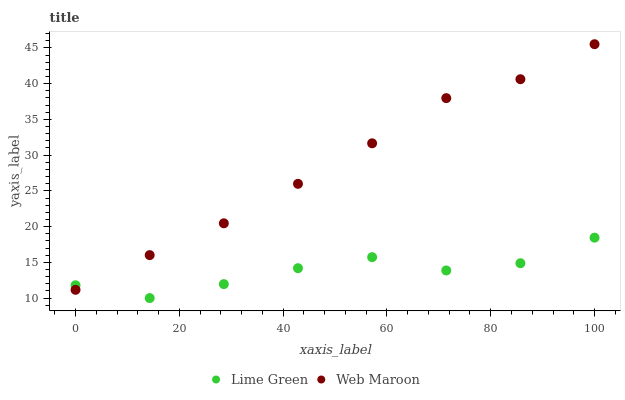Does Lime Green have the minimum area under the curve?
Answer yes or no. Yes. Does Web Maroon have the maximum area under the curve?
Answer yes or no. Yes. Does Lime Green have the maximum area under the curve?
Answer yes or no. No. Is Web Maroon the smoothest?
Answer yes or no. Yes. Is Lime Green the roughest?
Answer yes or no. Yes. Is Lime Green the smoothest?
Answer yes or no. No. Does Lime Green have the lowest value?
Answer yes or no. Yes. Does Web Maroon have the highest value?
Answer yes or no. Yes. Does Lime Green have the highest value?
Answer yes or no. No. Does Lime Green intersect Web Maroon?
Answer yes or no. Yes. Is Lime Green less than Web Maroon?
Answer yes or no. No. Is Lime Green greater than Web Maroon?
Answer yes or no. No. 